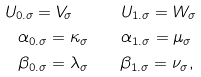Convert formula to latex. <formula><loc_0><loc_0><loc_500><loc_500>U _ { 0 . \sigma } = V _ { \sigma } \quad & \quad U _ { 1 . \sigma } = W _ { \sigma } \\ \alpha _ { 0 . \sigma } = \kappa _ { \sigma } \quad & \quad \alpha _ { 1 . \sigma } = \mu _ { \sigma } \\ \beta _ { 0 . \sigma } = \lambda _ { \sigma } \quad & \quad \beta _ { 1 . \sigma } = \nu _ { \sigma } ,</formula> 